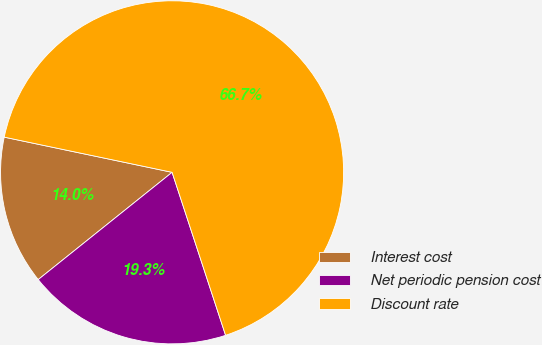Convert chart to OTSL. <chart><loc_0><loc_0><loc_500><loc_500><pie_chart><fcel>Interest cost<fcel>Net periodic pension cost<fcel>Discount rate<nl><fcel>14.04%<fcel>19.3%<fcel>66.67%<nl></chart> 